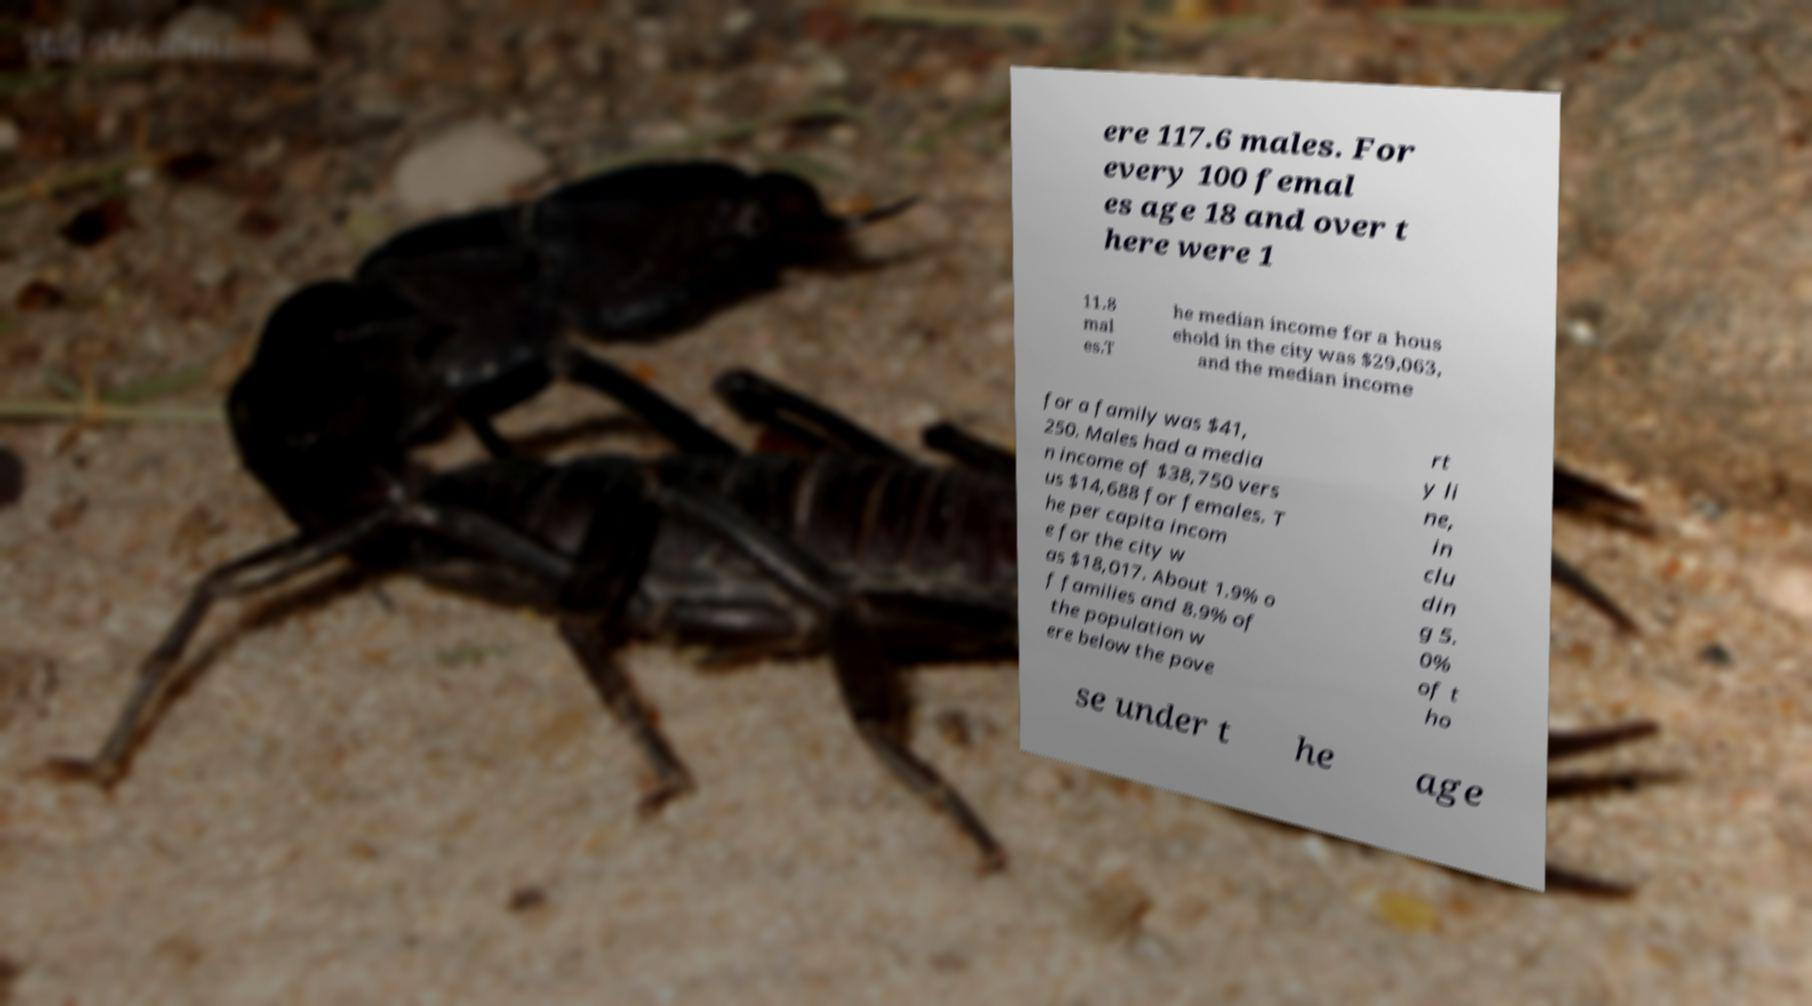Please read and relay the text visible in this image. What does it say? ere 117.6 males. For every 100 femal es age 18 and over t here were 1 11.8 mal es.T he median income for a hous ehold in the city was $29,063, and the median income for a family was $41, 250. Males had a media n income of $38,750 vers us $14,688 for females. T he per capita incom e for the city w as $18,017. About 1.9% o f families and 8.9% of the population w ere below the pove rt y li ne, in clu din g 5. 0% of t ho se under t he age 